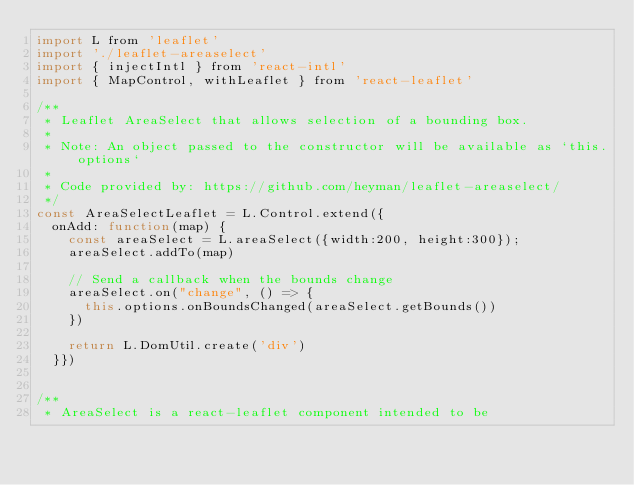Convert code to text. <code><loc_0><loc_0><loc_500><loc_500><_JavaScript_>import L from 'leaflet'
import './leaflet-areaselect'
import { injectIntl } from 'react-intl'
import { MapControl, withLeaflet } from 'react-leaflet'

/**
 * Leaflet AreaSelect that allows selection of a bounding box.
 *
 * Note: An object passed to the constructor will be available as `this.options`
 *
 * Code provided by: https://github.com/heyman/leaflet-areaselect/
 */
const AreaSelectLeaflet = L.Control.extend({
  onAdd: function(map) {
    const areaSelect = L.areaSelect({width:200, height:300});
    areaSelect.addTo(map)

    // Send a callback when the bounds change
    areaSelect.on("change", () => {
      this.options.onBoundsChanged(areaSelect.getBounds())
    })

    return L.DomUtil.create('div')
  }})


/**
 * AreaSelect is a react-leaflet component intended to be</code> 